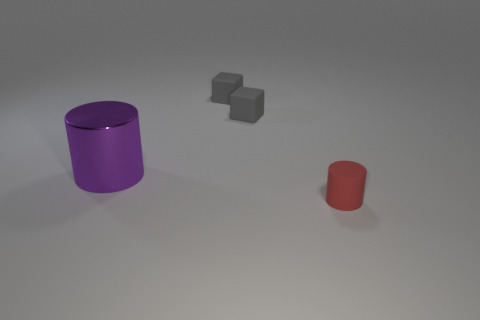Add 2 tiny rubber cylinders. How many objects exist? 6 Subtract all purple cylinders. How many cylinders are left? 1 Subtract 0 brown balls. How many objects are left? 4 Subtract 1 cylinders. How many cylinders are left? 1 Subtract all brown cylinders. Subtract all blue cubes. How many cylinders are left? 2 Subtract all small red matte objects. Subtract all gray objects. How many objects are left? 1 Add 4 large things. How many large things are left? 5 Add 4 large shiny things. How many large shiny things exist? 5 